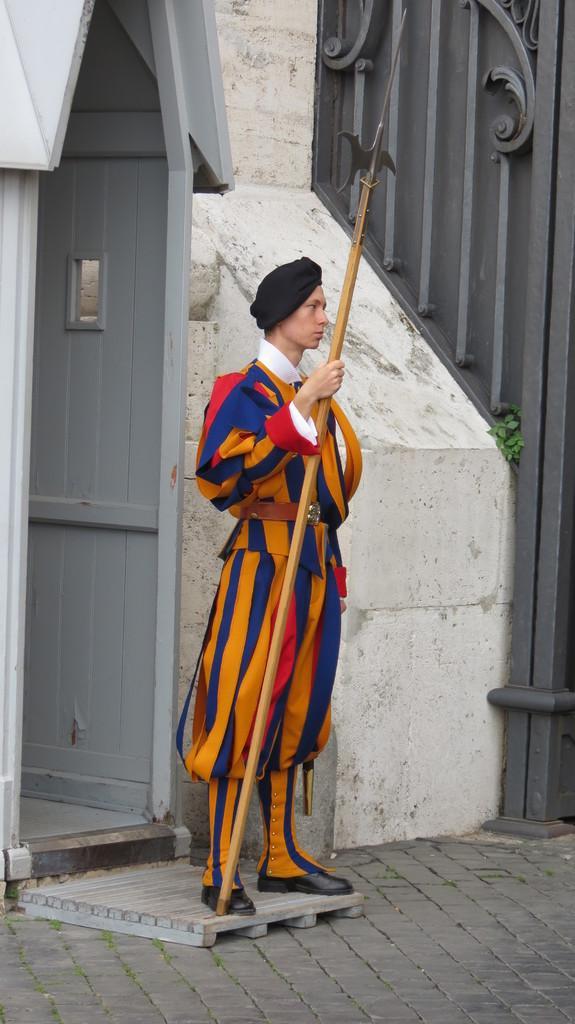Could you give a brief overview of what you see in this image? In this image in front there is a person holding the stick. behind him there is a door. At the bottom of the image there is a pavement. On the right side of the image there is a gate. 